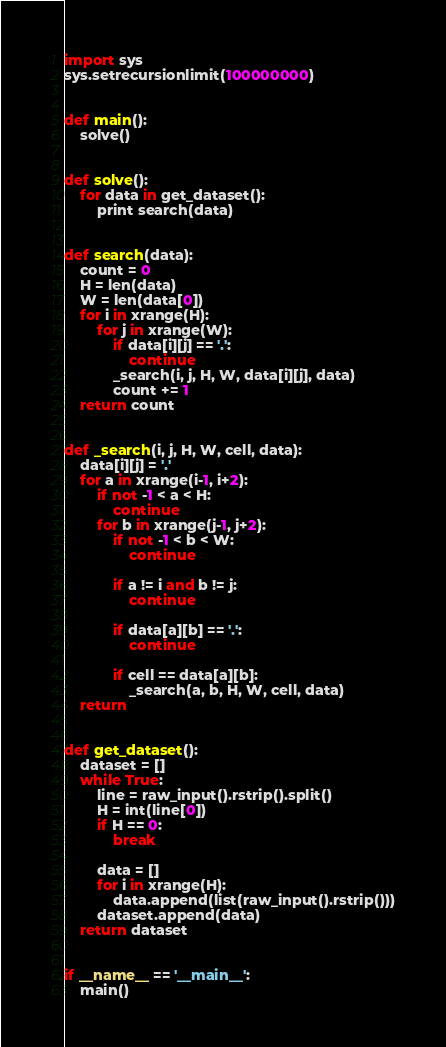Convert code to text. <code><loc_0><loc_0><loc_500><loc_500><_Python_>import sys
sys.setrecursionlimit(100000000)


def main():
    solve()


def solve():
    for data in get_dataset():
        print search(data)


def search(data):
    count = 0
    H = len(data)
    W = len(data[0])
    for i in xrange(H):
        for j in xrange(W):
            if data[i][j] == '.':
                continue
            _search(i, j, H, W, data[i][j], data)
            count += 1
    return count


def _search(i, j, H, W, cell, data):
    data[i][j] = '.'
    for a in xrange(i-1, i+2):
        if not -1 < a < H:
            continue
        for b in xrange(j-1, j+2):
            if not -1 < b < W:
                continue

            if a != i and b != j:
                continue

            if data[a][b] == '.':
                continue

            if cell == data[a][b]:
                _search(a, b, H, W, cell, data)
    return


def get_dataset():
    dataset = []
    while True:
        line = raw_input().rstrip().split()
        H = int(line[0])
        if H == 0:
            break

        data = []
        for i in xrange(H):
            data.append(list(raw_input().rstrip()))
        dataset.append(data)
    return dataset


if __name__ == '__main__':
    main()</code> 